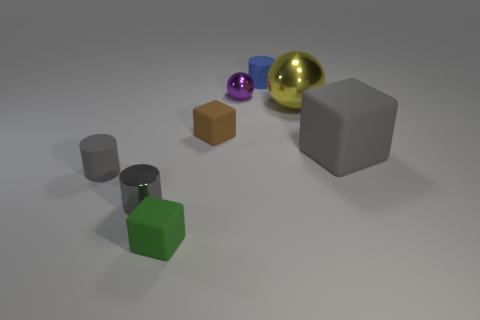Add 1 small cyan matte cylinders. How many objects exist? 9 Subtract all cylinders. How many objects are left? 5 Subtract 0 green spheres. How many objects are left? 8 Subtract all large yellow matte cylinders. Subtract all tiny brown objects. How many objects are left? 7 Add 6 big gray objects. How many big gray objects are left? 7 Add 3 large cyan matte things. How many large cyan matte things exist? 3 